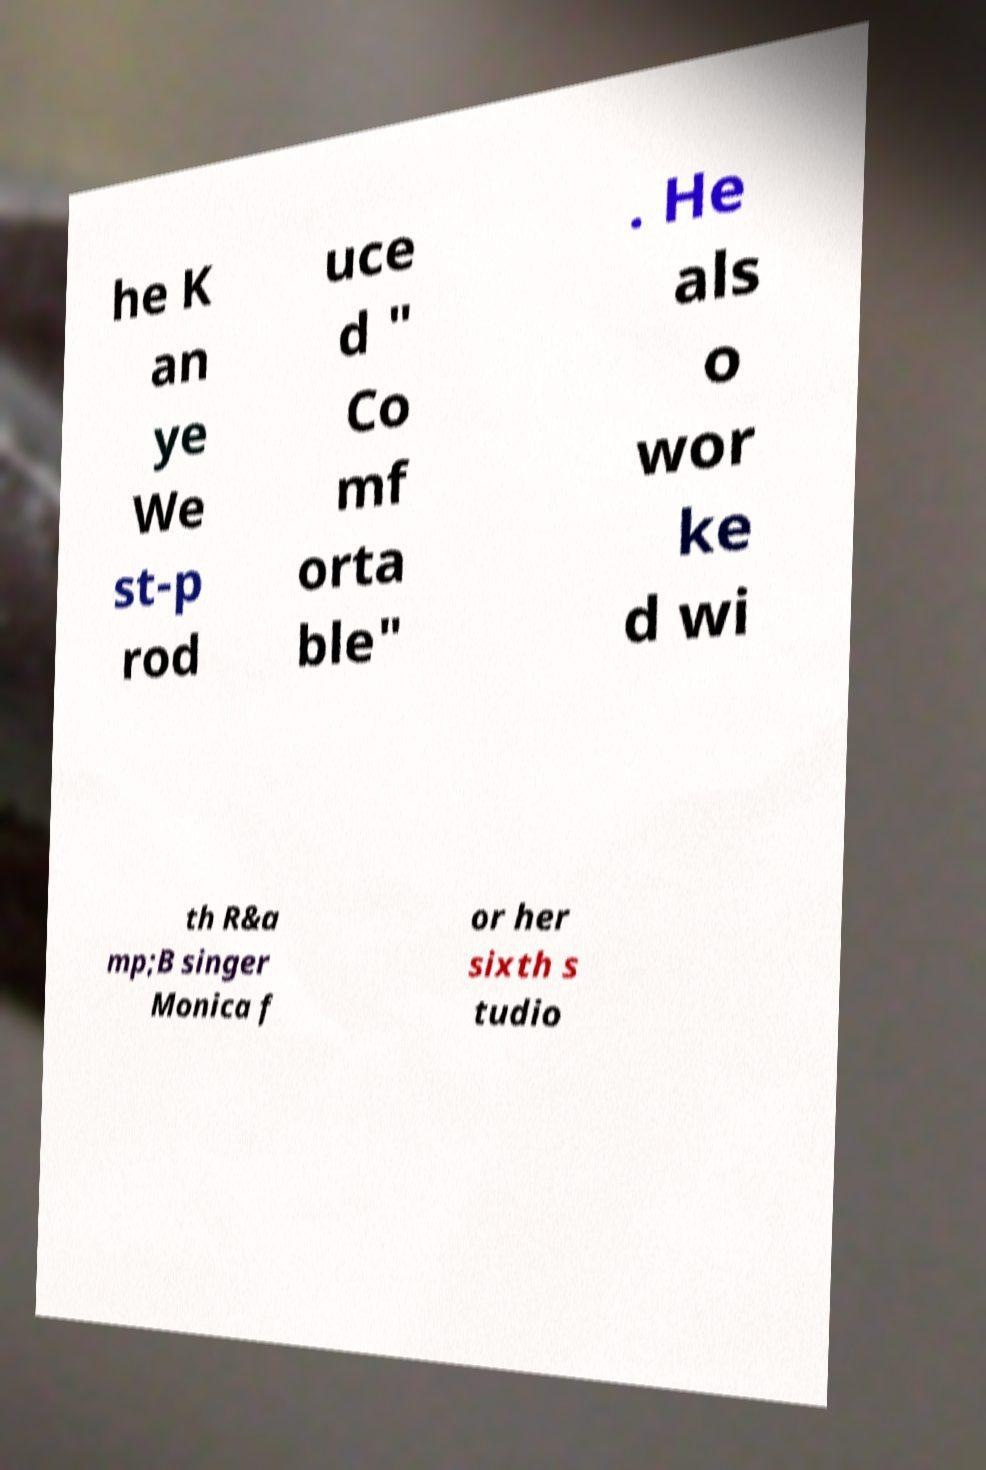Please identify and transcribe the text found in this image. he K an ye We st-p rod uce d " Co mf orta ble" . He als o wor ke d wi th R&a mp;B singer Monica f or her sixth s tudio 